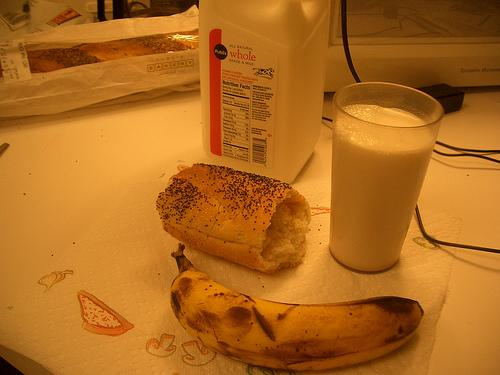Identify the type of fruit in the image and its condition. There's a yellow banana with brown bruises on the table. What can you infer about the type of milk in the image? The image shows a plastic half-gallon of whole milk. Mention the type of bread seen in the image along with its toppings. There's a piece of French bread topped with poppy seeds in the image. What type of glassware can you see in the image and what does it contain? There is a clear colored glass, and it contains white milk. List three main items available on the table in the image. A chunk of bread, a banana with brown bruises, and a glass of milk are on the table. Provide information about the type of container holding the milk in the image. The milk container is a white-colored plastic milk jug with a white, black, and red-colored label on it. What do you see lying under the glass of milk in the image? A paper towel with pictures of vegetables is lying under the glass of milk. Describe the condition of the banana on the table and any noticeable details. The unpeeled banana on the table is turning brown, and it has brown marks on it. Describe the appearance of the paper towel and what is it supporting in the image. The paper towel has a pattern of vegetables on it and is supporting the food items like a glass of milk, a banana, and a piece of bread. Is there any electronic appliance on the table in the image? Yes, a white toaster oven with its electronic cord is on the table. 